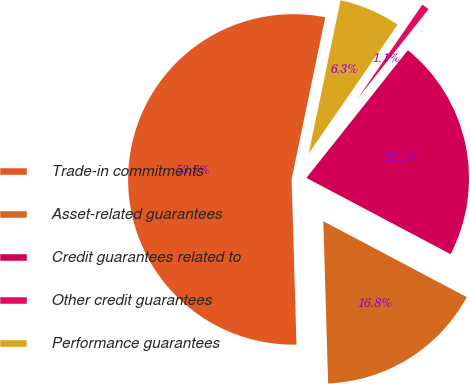<chart> <loc_0><loc_0><loc_500><loc_500><pie_chart><fcel>Trade-in commitments<fcel>Asset-related guarantees<fcel>Credit guarantees related to<fcel>Other credit guarantees<fcel>Performance guarantees<nl><fcel>53.73%<fcel>16.79%<fcel>22.06%<fcel>1.08%<fcel>6.34%<nl></chart> 